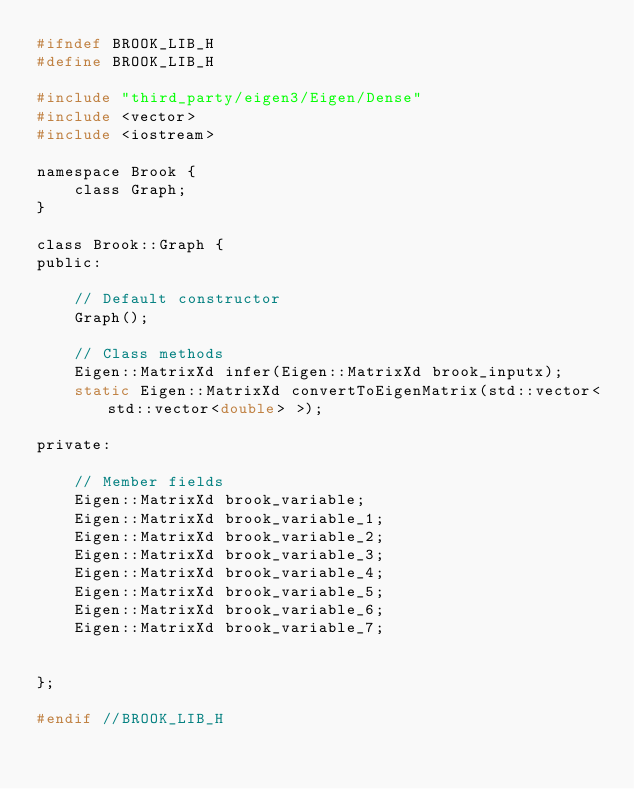<code> <loc_0><loc_0><loc_500><loc_500><_C_>#ifndef BROOK_LIB_H
#define BROOK_LIB_H

#include "third_party/eigen3/Eigen/Dense"
#include <vector>
#include <iostream>

namespace Brook {
    class Graph;
}

class Brook::Graph {
public:

    // Default constructor
    Graph();

    // Class methods
    Eigen::MatrixXd infer(Eigen::MatrixXd brook_inputx);
    static Eigen::MatrixXd convertToEigenMatrix(std::vector<std::vector<double> >);

private:

    // Member fields
    Eigen::MatrixXd brook_variable;
    Eigen::MatrixXd brook_variable_1;
    Eigen::MatrixXd brook_variable_2;
    Eigen::MatrixXd brook_variable_3;
    Eigen::MatrixXd brook_variable_4;
    Eigen::MatrixXd brook_variable_5;
    Eigen::MatrixXd brook_variable_6;
    Eigen::MatrixXd brook_variable_7;
    

};

#endif //BROOK_LIB_H
</code> 